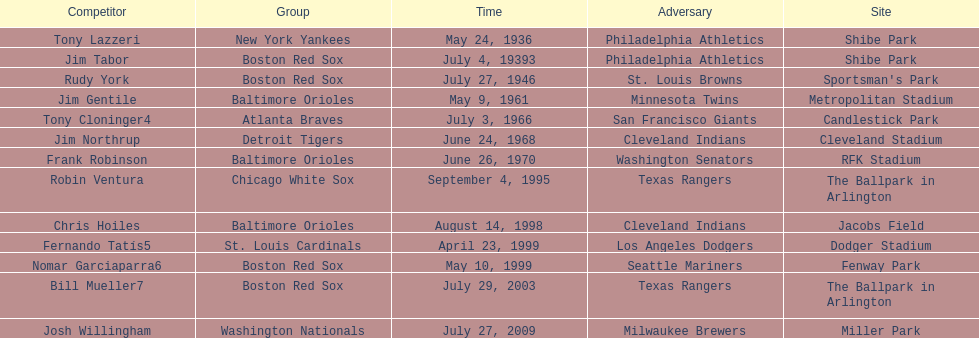Could you parse the entire table as a dict? {'header': ['Competitor', 'Group', 'Time', 'Adversary', 'Site'], 'rows': [['Tony Lazzeri', 'New York Yankees', 'May 24, 1936', 'Philadelphia Athletics', 'Shibe Park'], ['Jim Tabor', 'Boston Red Sox', 'July 4, 19393', 'Philadelphia Athletics', 'Shibe Park'], ['Rudy York', 'Boston Red Sox', 'July 27, 1946', 'St. Louis Browns', "Sportsman's Park"], ['Jim Gentile', 'Baltimore Orioles', 'May 9, 1961', 'Minnesota Twins', 'Metropolitan Stadium'], ['Tony Cloninger4', 'Atlanta Braves', 'July 3, 1966', 'San Francisco Giants', 'Candlestick Park'], ['Jim Northrup', 'Detroit Tigers', 'June 24, 1968', 'Cleveland Indians', 'Cleveland Stadium'], ['Frank Robinson', 'Baltimore Orioles', 'June 26, 1970', 'Washington Senators', 'RFK Stadium'], ['Robin Ventura', 'Chicago White Sox', 'September 4, 1995', 'Texas Rangers', 'The Ballpark in Arlington'], ['Chris Hoiles', 'Baltimore Orioles', 'August 14, 1998', 'Cleveland Indians', 'Jacobs Field'], ['Fernando Tatís5', 'St. Louis Cardinals', 'April 23, 1999', 'Los Angeles Dodgers', 'Dodger Stadium'], ['Nomar Garciaparra6', 'Boston Red Sox', 'May 10, 1999', 'Seattle Mariners', 'Fenway Park'], ['Bill Mueller7', 'Boston Red Sox', 'July 29, 2003', 'Texas Rangers', 'The Ballpark in Arlington'], ['Josh Willingham', 'Washington Nationals', 'July 27, 2009', 'Milwaukee Brewers', 'Miller Park']]} What is the name of the player for the new york yankees in 1936? Tony Lazzeri. 